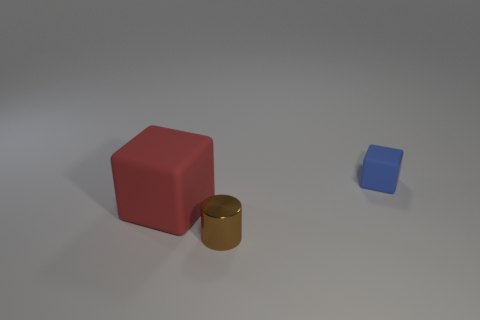The matte block that is left of the tiny blue thing is what color?
Give a very brief answer. Red. Is there any other thing that is the same color as the small metallic thing?
Offer a terse response. No. Are there more blue cubes that are to the right of the blue matte cube than cubes to the right of the brown metal cylinder?
Give a very brief answer. No. How many red matte objects have the same size as the blue matte thing?
Provide a short and direct response. 0. Are there fewer small cylinders that are right of the brown thing than objects behind the tiny blue rubber object?
Keep it short and to the point. No. Are there any blue matte objects that have the same shape as the red object?
Make the answer very short. Yes. Does the big red rubber object have the same shape as the small brown metallic object?
Offer a very short reply. No. What number of big things are either brown matte cubes or blue blocks?
Provide a succinct answer. 0. Is the number of brown metal cylinders greater than the number of gray matte things?
Offer a very short reply. Yes. There is a blue thing that is made of the same material as the large red thing; what is its size?
Make the answer very short. Small. 